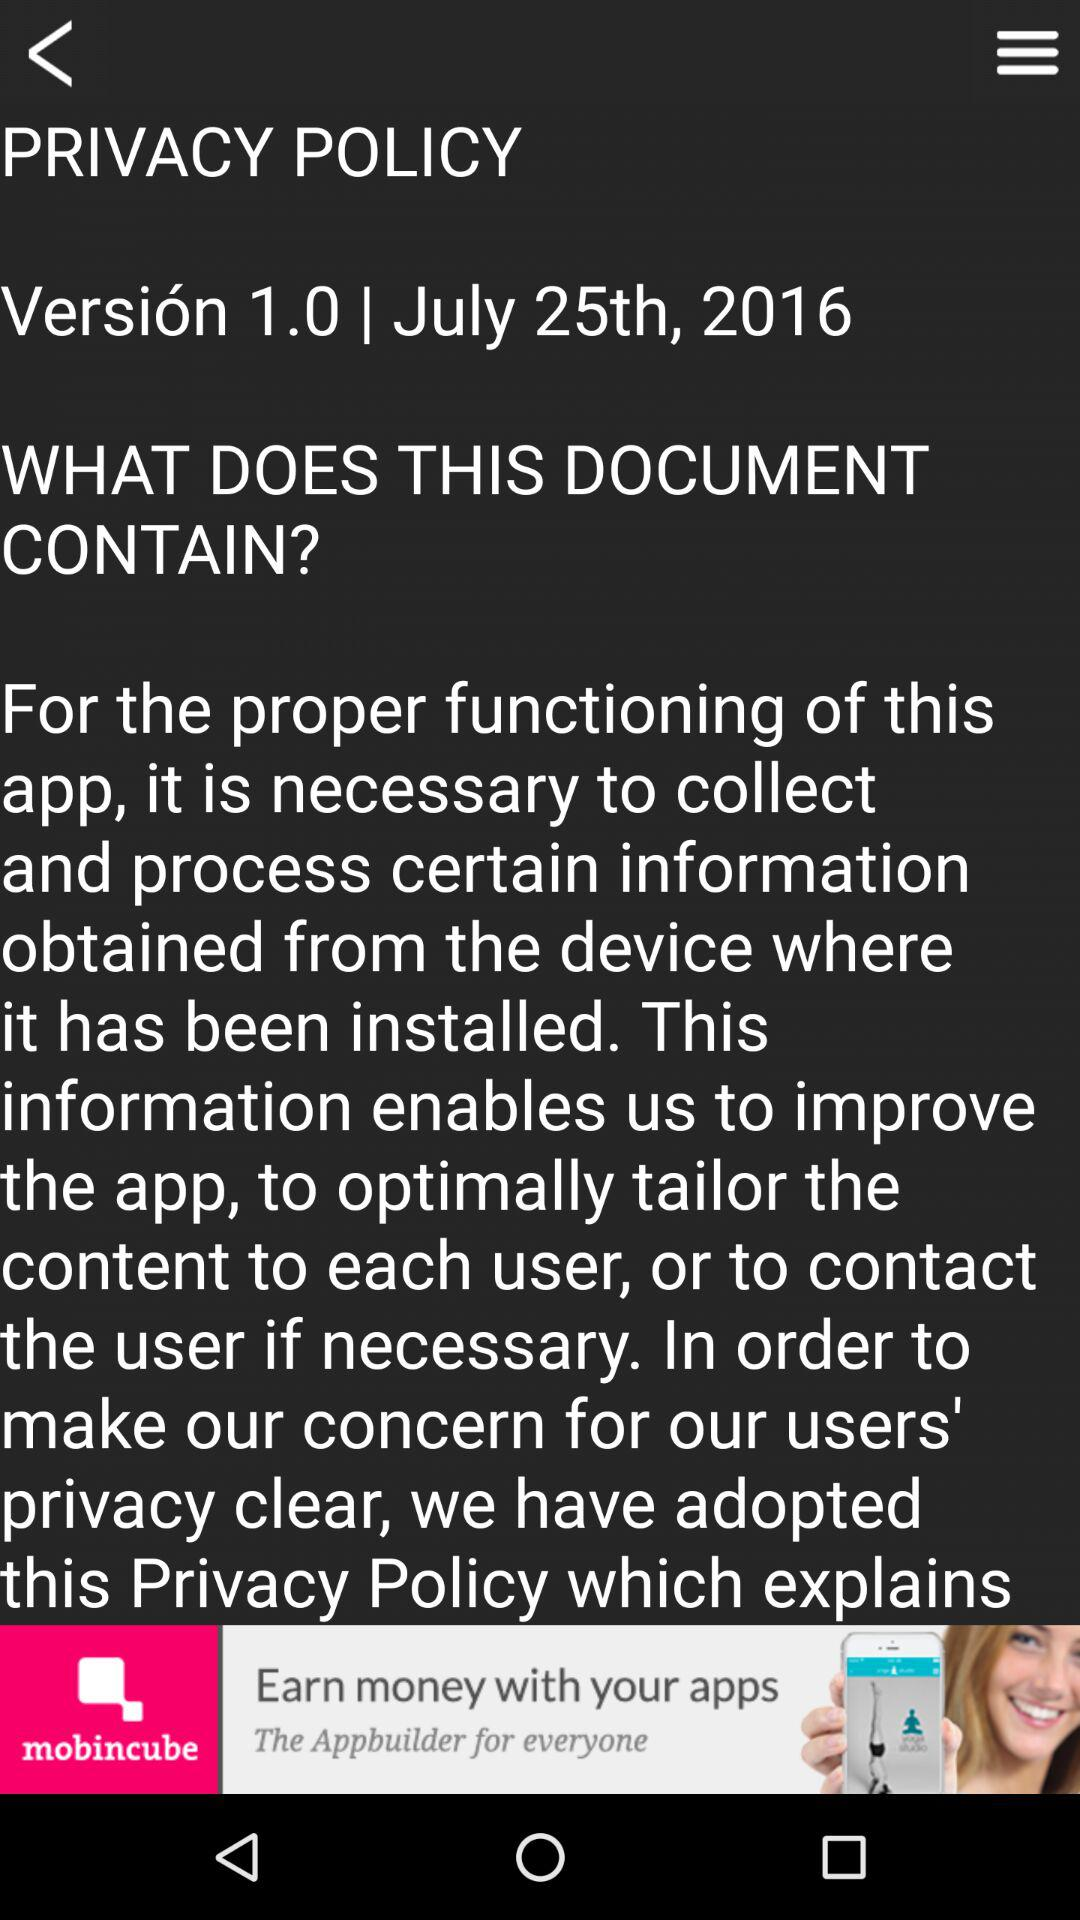What is the date and year? The date and year are July 25, 2016. 